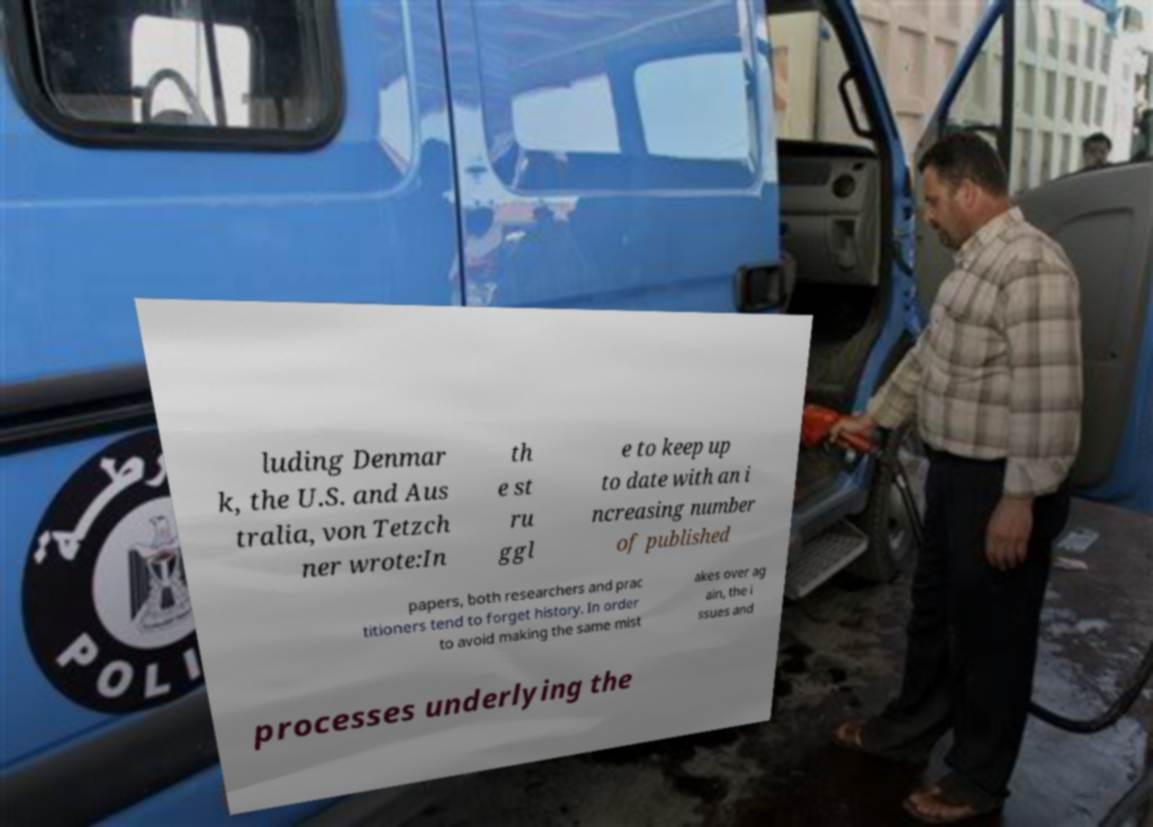I need the written content from this picture converted into text. Can you do that? luding Denmar k, the U.S. and Aus tralia, von Tetzch ner wrote:In th e st ru ggl e to keep up to date with an i ncreasing number of published papers, both researchers and prac titioners tend to forget history. In order to avoid making the same mist akes over ag ain, the i ssues and processes underlying the 